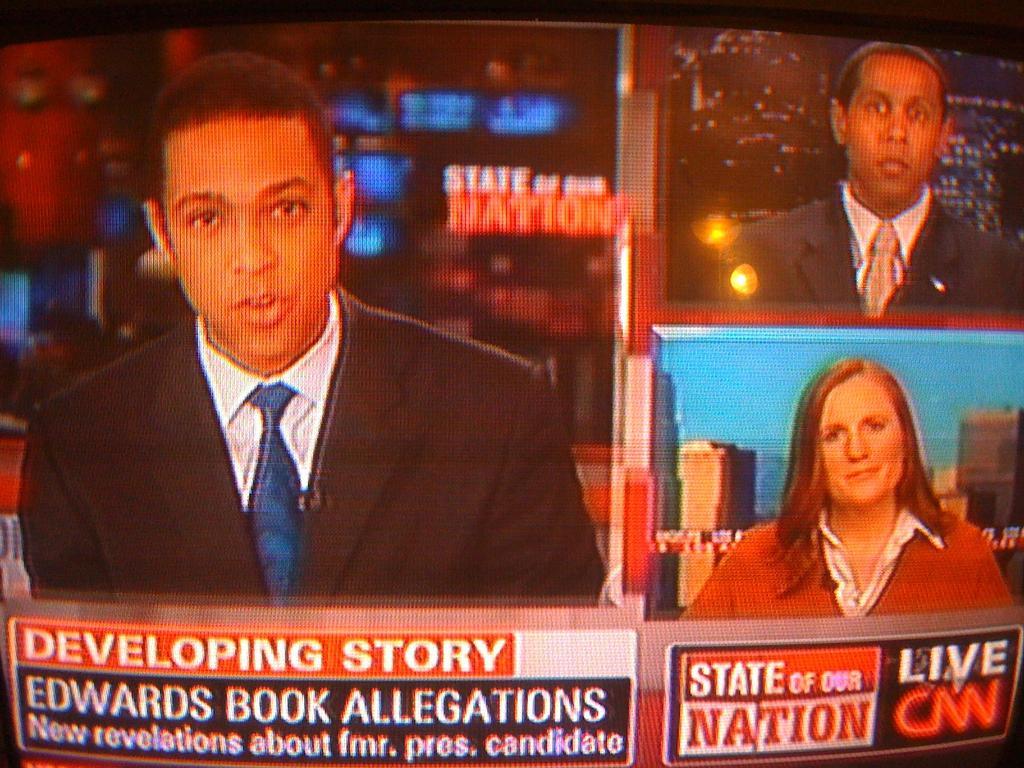In one or two sentences, can you explain what this image depicts? In this picture we can see a few people on a screen. 